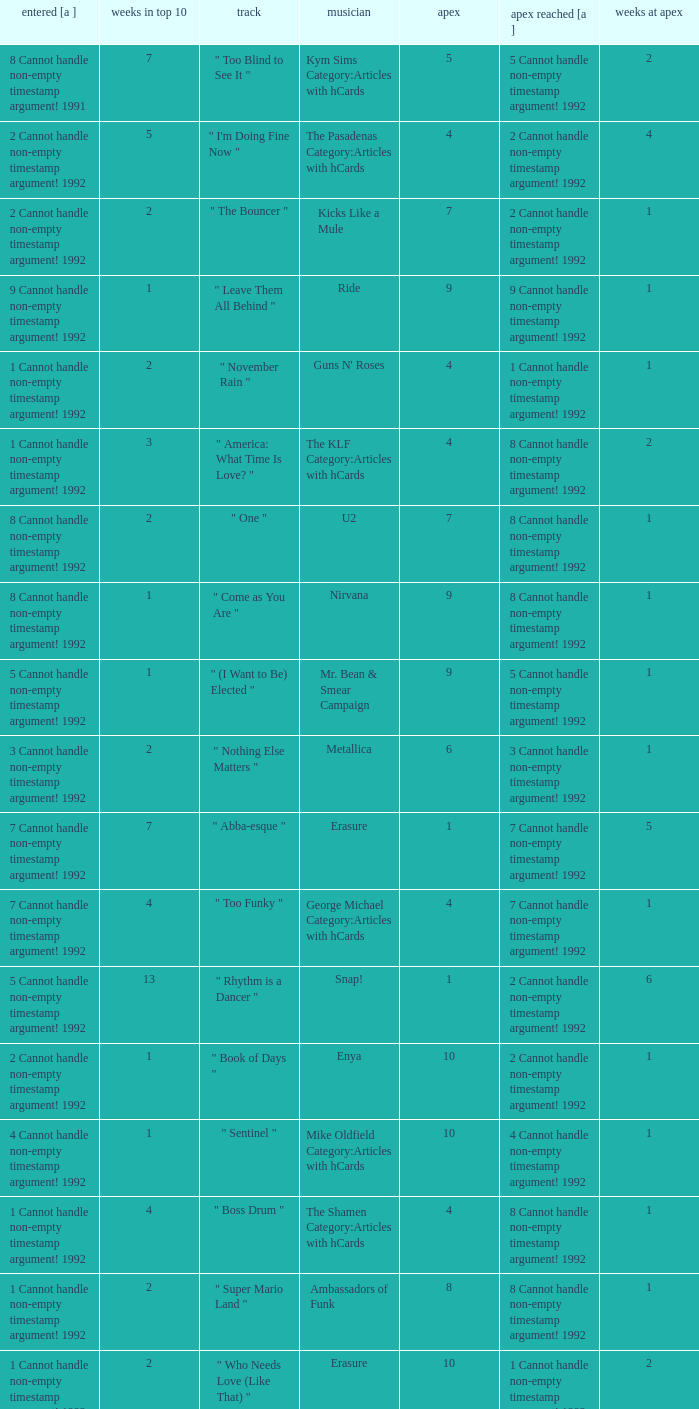If the peak reached is 6 cannot handle non-empty timestamp argument! 1992, what is the entered? 6 Cannot handle non-empty timestamp argument! 1992. 